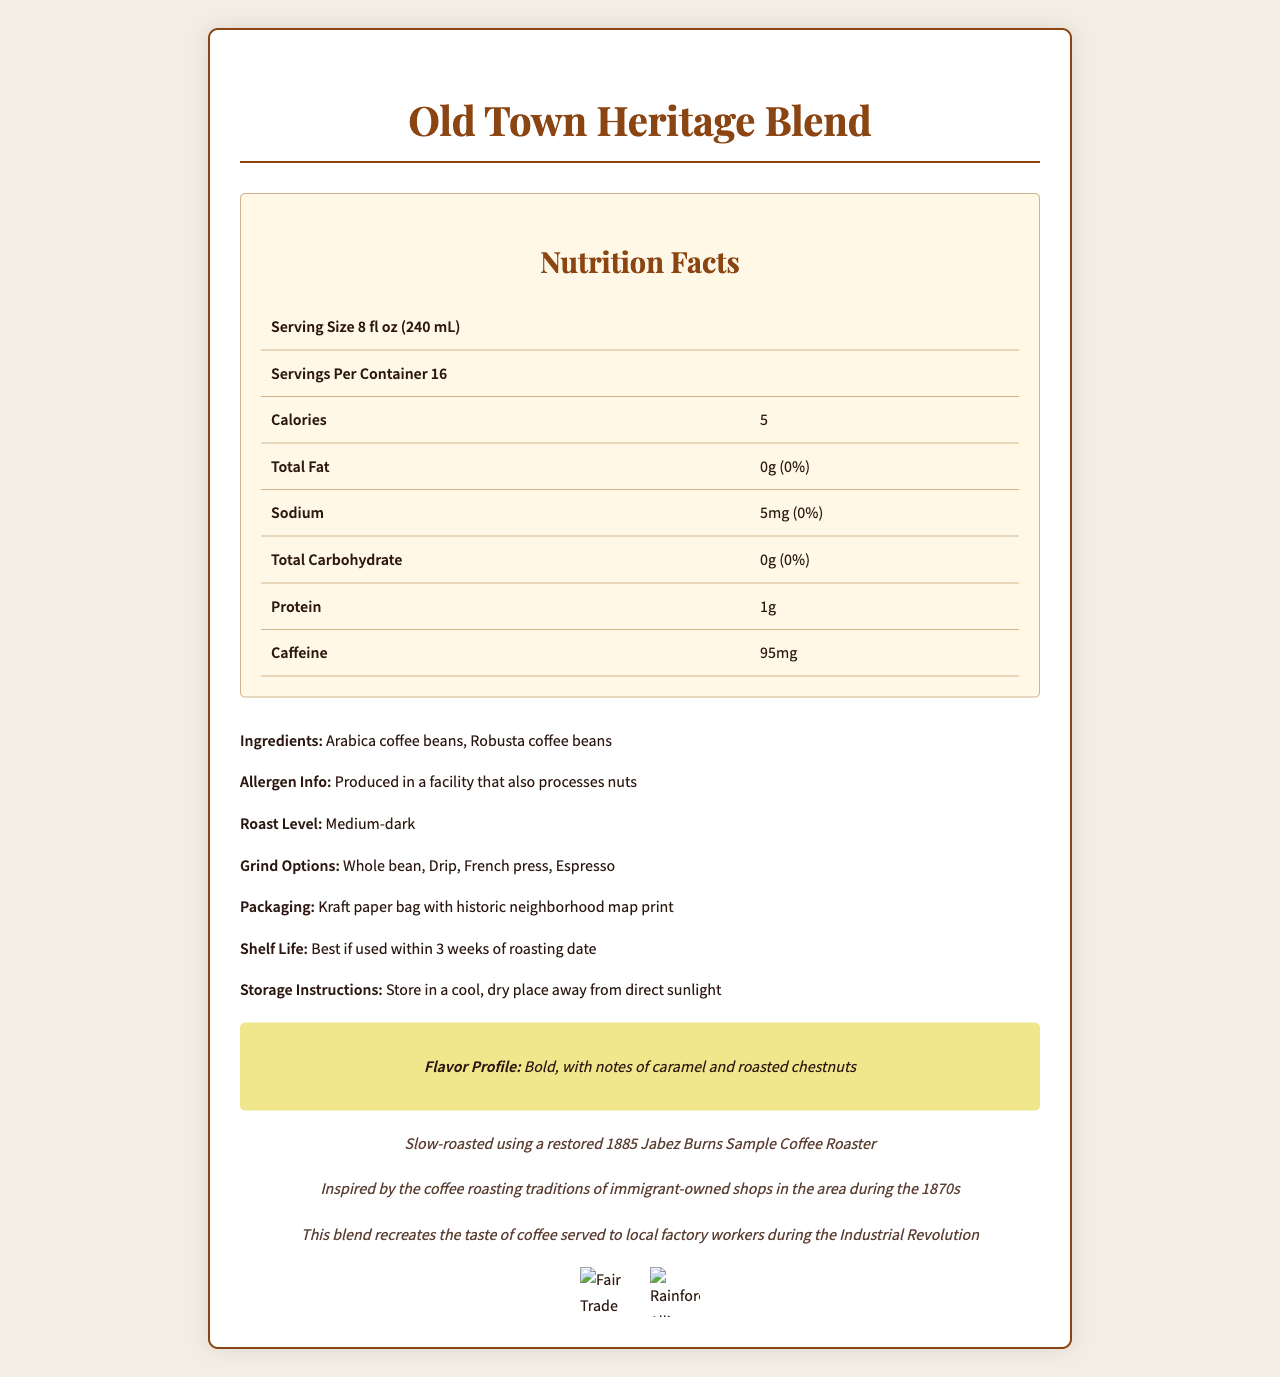what is the serving size? The serving size is explicitly stated as 8 fl oz (240 mL) in the Nutrition Facts section.
Answer: 8 fl oz (240 mL) how many calories are in one serving? The Nutrition Facts label indicates that there are 5 calories per serving.
Answer: 5 what is the sodium content per serving? According to the Nutrition Facts label, the sodium content per serving is 5mg.
Answer: 5mg list the main ingredients of the coffee blend The list of ingredients specifies Arabica coffee beans and Robusta coffee beans.
Answer: Arabica coffee beans, Robusta coffee beans how many servings are in the container? The document states that there are 16 servings per container.
Answer: 16 which roasting technique is used for this blend? A. Fast roasting B. Medium-fast roasting C. Slow roasting The historic roasting technique used is 'Slow-roasted using a restored 1885 Jabez Burns Sample Coffee Roaster'.
Answer: C what is the roast level of this coffee blend? The roast level mentioned in the document is Medium-dark.
Answer: Medium-dark where do the Arabica beans originate from? A. Colombian highlands B. Ethiopian highlands C. Brazilian highlands The Arabica beans originate from the Colombian highlands.
Answer: A does the document indicate if the product is Fair Trade certified? The certifications section shows that the product is Fair Trade certified.
Answer: Yes how much caffeine does one serving contain? The Nutrition Facts label lists 95mg of caffeine per serving.
Answer: 95mg describe the flavor profile of the Old Town Heritage Blend The document specifically describes the flavor profile as "Bold, with notes of caramel and roasted chestnuts".
Answer: Bold, with notes of caramel and roasted chestnuts what is the history behind the coffee blend? The document provides historical context, stating that the blend is inspired by the coffee roasting traditions of immigrant-owned shops in the area during the 1870s.
Answer: Inspired by the coffee roasting traditions of immigrant-owned shops in the area during the 1870s what is the daily value percentage of total fat per serving? The document indicates that the total fat per serving is 0g, which corresponds to 0% of the daily value.
Answer: 0% does this coffee blend contain nuts? Although the coffee itself doesn't list nuts as an ingredient, the allergen info mentions it is produced in a facility that also processes nuts. This doesn't confirm the presence of nuts in the blend itself.
Answer: Not enough information what type of packaging is used for the coffee? The document mentions the coffee is packaged in a Kraft paper bag with a historic neighborhood map print.
Answer: Kraft paper bag with historic neighborhood map print what is the best way to store this coffee? The document advises storing the coffee in a cool, dry place away from direct sunlight.
Answer: Store in a cool, dry place away from direct sunlight how would you summarize the main features of the Old Town Heritage Blend? The summary covers the blend's origin, flavor profile, nutritional information, ingredients, and certifications, as well as historical and packaging details.
Answer: The Old Town Heritage Blend is a medium-dark roast coffee inspired by 19th-century neighborhood traditions, with a bold flavor profile featuring notes of caramel and roasted chestnuts. It contains 5 calories and 95mg of caffeine per 8 fl oz serving and is made from Arabica and Robusta beans sourced from the Colombian highlands and Vietnamese Central Highlands, respectively. The coffee is slow-roasted using a historic technique and is Fair Trade and Rainforest Alliance certified. It is packaged in a Kraft paper bag with a neighborhood map print. what is the recommended water temperature for brewing this coffee? The document recommends a water temperature of 195-205°F (90-96°C) for brewing.
Answer: 195-205°F (90-96°C) 